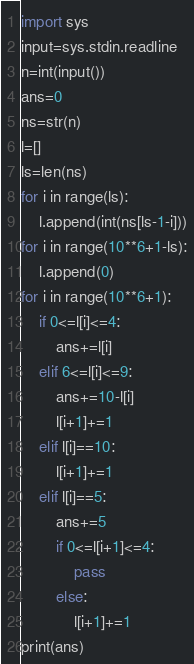<code> <loc_0><loc_0><loc_500><loc_500><_Python_>import sys
input=sys.stdin.readline
n=int(input())
ans=0
ns=str(n)
l=[]
ls=len(ns)
for i in range(ls):
    l.append(int(ns[ls-1-i]))
for i in range(10**6+1-ls):
    l.append(0)
for i in range(10**6+1):
    if 0<=l[i]<=4:
        ans+=l[i]
    elif 6<=l[i]<=9:
        ans+=10-l[i]
        l[i+1]+=1
    elif l[i]==10:
        l[i+1]+=1
    elif l[i]==5:
        ans+=5
        if 0<=l[i+1]<=4:
            pass
        else:
            l[i+1]+=1
print(ans)






</code> 